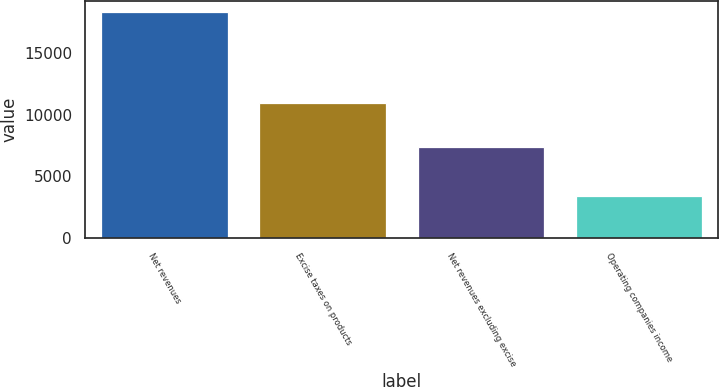Convert chart to OTSL. <chart><loc_0><loc_0><loc_500><loc_500><bar_chart><fcel>Net revenues<fcel>Excise taxes on products<fcel>Net revenues excluding excise<fcel>Operating companies income<nl><fcel>18328<fcel>10964<fcel>7364<fcel>3425<nl></chart> 